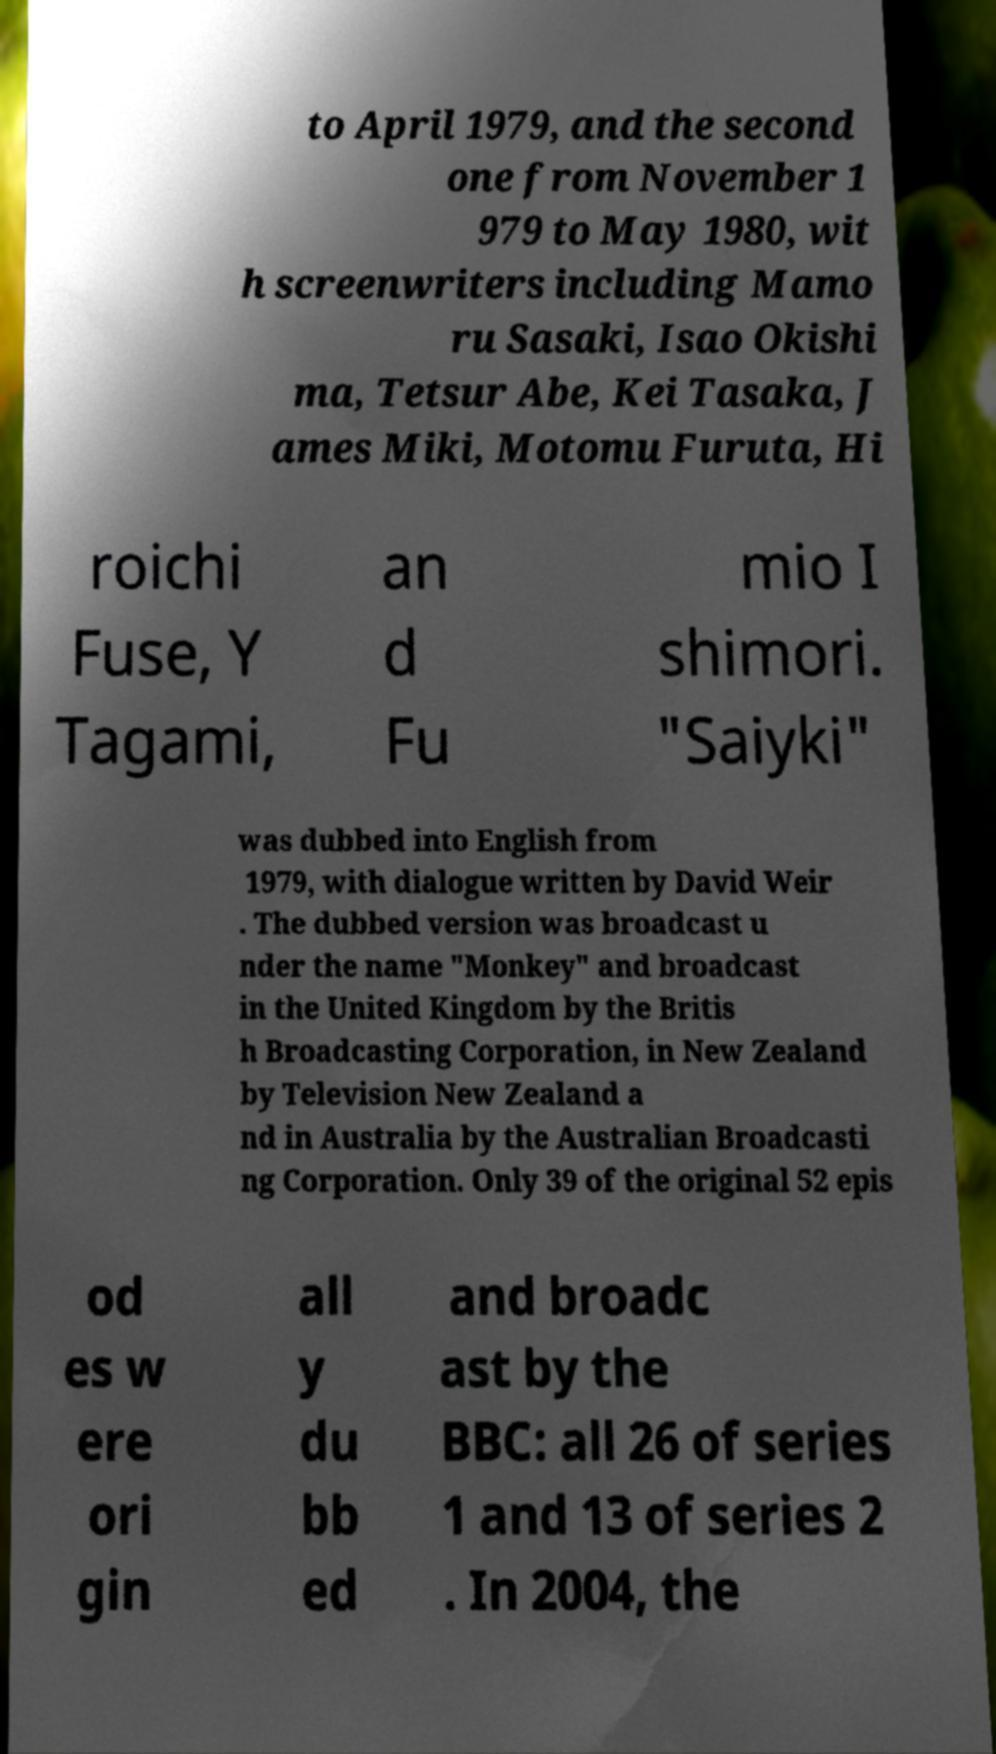Can you read and provide the text displayed in the image?This photo seems to have some interesting text. Can you extract and type it out for me? to April 1979, and the second one from November 1 979 to May 1980, wit h screenwriters including Mamo ru Sasaki, Isao Okishi ma, Tetsur Abe, Kei Tasaka, J ames Miki, Motomu Furuta, Hi roichi Fuse, Y Tagami, an d Fu mio I shimori. "Saiyki" was dubbed into English from 1979, with dialogue written by David Weir . The dubbed version was broadcast u nder the name "Monkey" and broadcast in the United Kingdom by the Britis h Broadcasting Corporation, in New Zealand by Television New Zealand a nd in Australia by the Australian Broadcasti ng Corporation. Only 39 of the original 52 epis od es w ere ori gin all y du bb ed and broadc ast by the BBC: all 26 of series 1 and 13 of series 2 . In 2004, the 